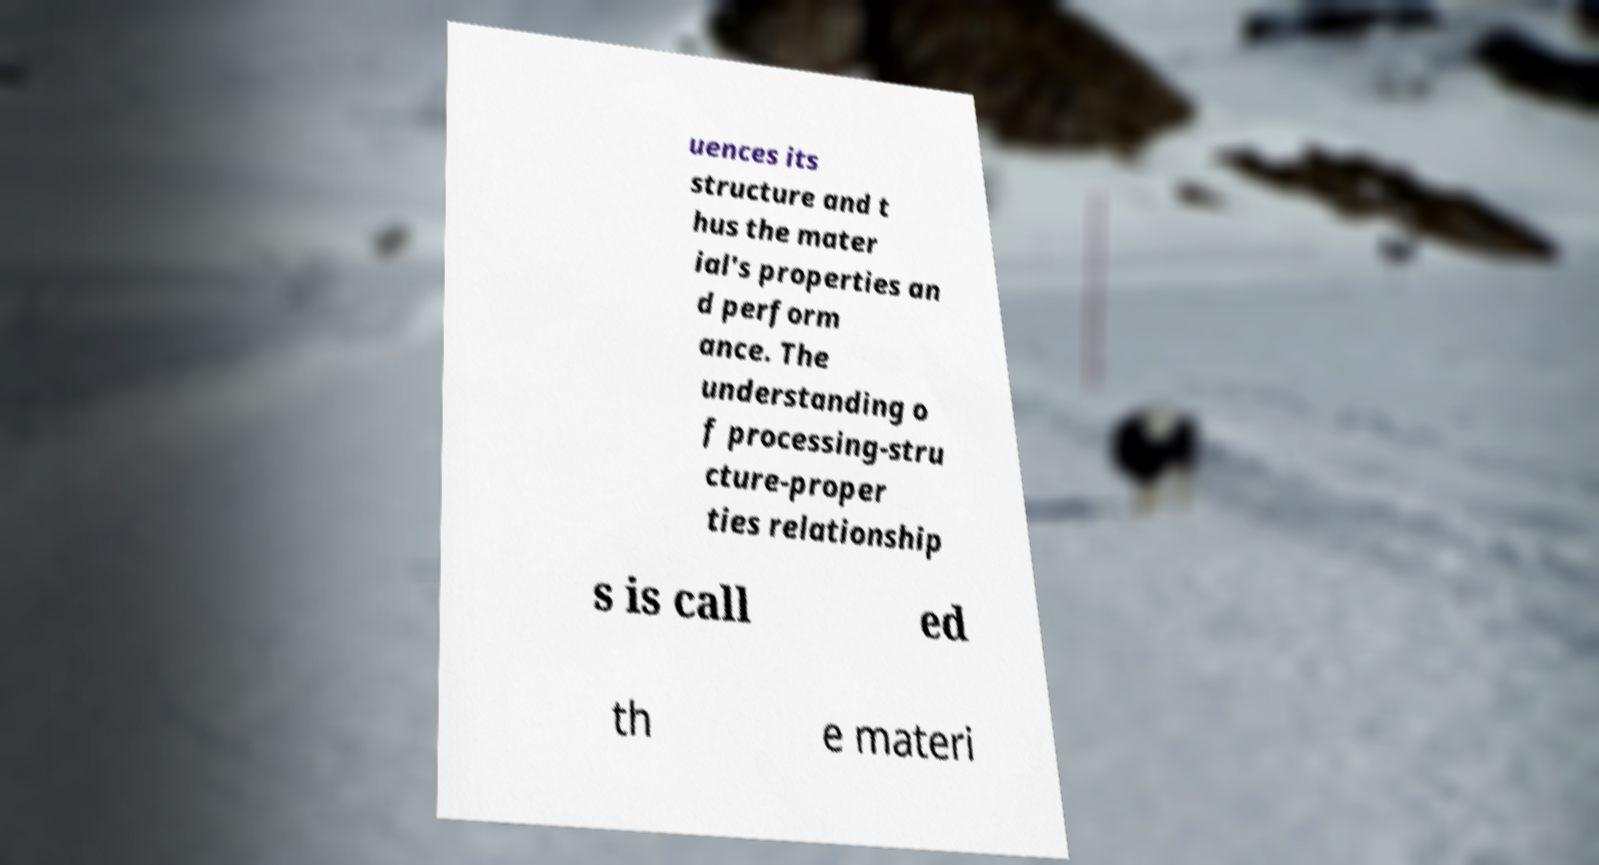Can you read and provide the text displayed in the image?This photo seems to have some interesting text. Can you extract and type it out for me? uences its structure and t hus the mater ial's properties an d perform ance. The understanding o f processing-stru cture-proper ties relationship s is call ed th e materi 